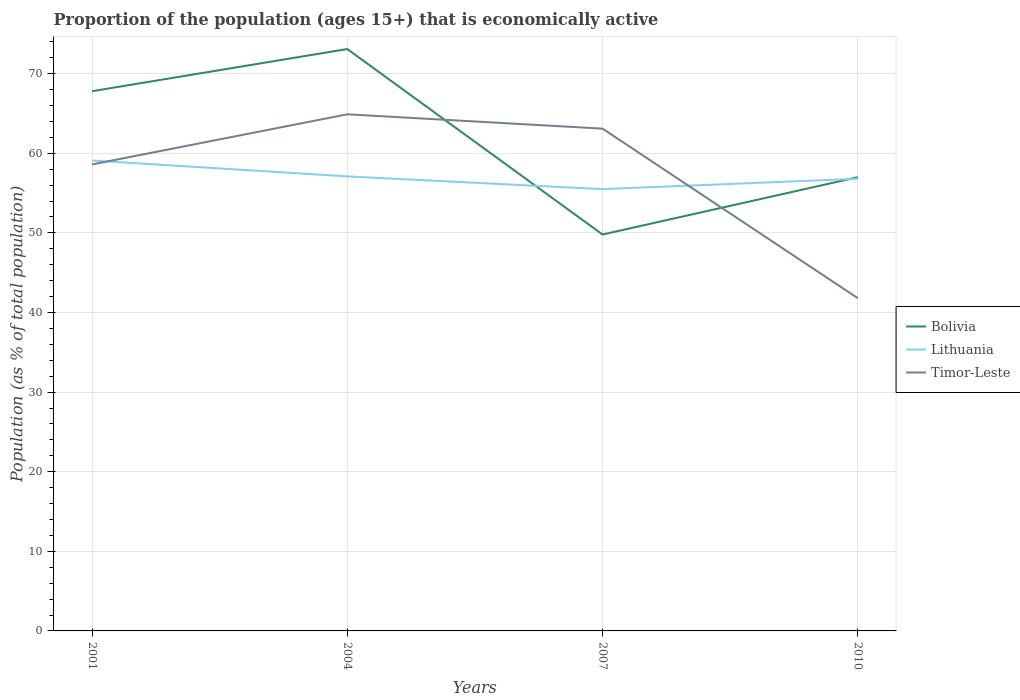How many different coloured lines are there?
Your answer should be compact. 3. Across all years, what is the maximum proportion of the population that is economically active in Bolivia?
Provide a succinct answer. 49.8. In which year was the proportion of the population that is economically active in Timor-Leste maximum?
Offer a terse response. 2010. What is the total proportion of the population that is economically active in Timor-Leste in the graph?
Give a very brief answer. 21.3. What is the difference between the highest and the second highest proportion of the population that is economically active in Timor-Leste?
Offer a terse response. 23.1. Is the proportion of the population that is economically active in Bolivia strictly greater than the proportion of the population that is economically active in Lithuania over the years?
Offer a terse response. No. How many lines are there?
Your answer should be compact. 3. How many years are there in the graph?
Your answer should be compact. 4. Does the graph contain grids?
Offer a very short reply. Yes. How many legend labels are there?
Your answer should be compact. 3. What is the title of the graph?
Your answer should be very brief. Proportion of the population (ages 15+) that is economically active. Does "Switzerland" appear as one of the legend labels in the graph?
Offer a very short reply. No. What is the label or title of the Y-axis?
Give a very brief answer. Population (as % of total population). What is the Population (as % of total population) in Bolivia in 2001?
Offer a very short reply. 67.8. What is the Population (as % of total population) in Lithuania in 2001?
Make the answer very short. 59.1. What is the Population (as % of total population) in Timor-Leste in 2001?
Provide a succinct answer. 58.6. What is the Population (as % of total population) in Bolivia in 2004?
Ensure brevity in your answer.  73.1. What is the Population (as % of total population) of Lithuania in 2004?
Offer a terse response. 57.1. What is the Population (as % of total population) in Timor-Leste in 2004?
Give a very brief answer. 64.9. What is the Population (as % of total population) in Bolivia in 2007?
Your response must be concise. 49.8. What is the Population (as % of total population) in Lithuania in 2007?
Keep it short and to the point. 55.5. What is the Population (as % of total population) in Timor-Leste in 2007?
Offer a terse response. 63.1. What is the Population (as % of total population) of Bolivia in 2010?
Your response must be concise. 57. What is the Population (as % of total population) in Lithuania in 2010?
Your response must be concise. 56.8. What is the Population (as % of total population) in Timor-Leste in 2010?
Your response must be concise. 41.8. Across all years, what is the maximum Population (as % of total population) in Bolivia?
Provide a short and direct response. 73.1. Across all years, what is the maximum Population (as % of total population) of Lithuania?
Make the answer very short. 59.1. Across all years, what is the maximum Population (as % of total population) of Timor-Leste?
Offer a terse response. 64.9. Across all years, what is the minimum Population (as % of total population) of Bolivia?
Offer a terse response. 49.8. Across all years, what is the minimum Population (as % of total population) of Lithuania?
Provide a succinct answer. 55.5. Across all years, what is the minimum Population (as % of total population) of Timor-Leste?
Provide a short and direct response. 41.8. What is the total Population (as % of total population) of Bolivia in the graph?
Your response must be concise. 247.7. What is the total Population (as % of total population) in Lithuania in the graph?
Offer a terse response. 228.5. What is the total Population (as % of total population) of Timor-Leste in the graph?
Give a very brief answer. 228.4. What is the difference between the Population (as % of total population) in Bolivia in 2001 and that in 2004?
Provide a short and direct response. -5.3. What is the difference between the Population (as % of total population) in Lithuania in 2001 and that in 2004?
Provide a short and direct response. 2. What is the difference between the Population (as % of total population) in Timor-Leste in 2001 and that in 2004?
Offer a very short reply. -6.3. What is the difference between the Population (as % of total population) in Lithuania in 2001 and that in 2007?
Offer a terse response. 3.6. What is the difference between the Population (as % of total population) in Timor-Leste in 2001 and that in 2007?
Offer a terse response. -4.5. What is the difference between the Population (as % of total population) of Lithuania in 2001 and that in 2010?
Keep it short and to the point. 2.3. What is the difference between the Population (as % of total population) of Timor-Leste in 2001 and that in 2010?
Make the answer very short. 16.8. What is the difference between the Population (as % of total population) in Bolivia in 2004 and that in 2007?
Offer a terse response. 23.3. What is the difference between the Population (as % of total population) of Timor-Leste in 2004 and that in 2007?
Provide a succinct answer. 1.8. What is the difference between the Population (as % of total population) in Bolivia in 2004 and that in 2010?
Provide a short and direct response. 16.1. What is the difference between the Population (as % of total population) of Lithuania in 2004 and that in 2010?
Ensure brevity in your answer.  0.3. What is the difference between the Population (as % of total population) of Timor-Leste in 2004 and that in 2010?
Provide a short and direct response. 23.1. What is the difference between the Population (as % of total population) of Timor-Leste in 2007 and that in 2010?
Offer a terse response. 21.3. What is the difference between the Population (as % of total population) in Bolivia in 2001 and the Population (as % of total population) in Lithuania in 2007?
Provide a succinct answer. 12.3. What is the difference between the Population (as % of total population) in Lithuania in 2001 and the Population (as % of total population) in Timor-Leste in 2007?
Your answer should be compact. -4. What is the difference between the Population (as % of total population) of Bolivia in 2001 and the Population (as % of total population) of Lithuania in 2010?
Keep it short and to the point. 11. What is the difference between the Population (as % of total population) of Bolivia in 2001 and the Population (as % of total population) of Timor-Leste in 2010?
Ensure brevity in your answer.  26. What is the difference between the Population (as % of total population) in Bolivia in 2004 and the Population (as % of total population) in Lithuania in 2007?
Ensure brevity in your answer.  17.6. What is the difference between the Population (as % of total population) in Bolivia in 2004 and the Population (as % of total population) in Timor-Leste in 2007?
Ensure brevity in your answer.  10. What is the difference between the Population (as % of total population) of Lithuania in 2004 and the Population (as % of total population) of Timor-Leste in 2007?
Provide a short and direct response. -6. What is the difference between the Population (as % of total population) in Bolivia in 2004 and the Population (as % of total population) in Timor-Leste in 2010?
Ensure brevity in your answer.  31.3. What is the difference between the Population (as % of total population) of Lithuania in 2004 and the Population (as % of total population) of Timor-Leste in 2010?
Ensure brevity in your answer.  15.3. What is the difference between the Population (as % of total population) of Bolivia in 2007 and the Population (as % of total population) of Lithuania in 2010?
Provide a succinct answer. -7. What is the average Population (as % of total population) in Bolivia per year?
Your response must be concise. 61.92. What is the average Population (as % of total population) in Lithuania per year?
Provide a short and direct response. 57.12. What is the average Population (as % of total population) in Timor-Leste per year?
Give a very brief answer. 57.1. In the year 2001, what is the difference between the Population (as % of total population) of Lithuania and Population (as % of total population) of Timor-Leste?
Ensure brevity in your answer.  0.5. In the year 2004, what is the difference between the Population (as % of total population) in Lithuania and Population (as % of total population) in Timor-Leste?
Ensure brevity in your answer.  -7.8. In the year 2007, what is the difference between the Population (as % of total population) of Bolivia and Population (as % of total population) of Lithuania?
Make the answer very short. -5.7. In the year 2007, what is the difference between the Population (as % of total population) in Bolivia and Population (as % of total population) in Timor-Leste?
Provide a succinct answer. -13.3. In the year 2010, what is the difference between the Population (as % of total population) of Bolivia and Population (as % of total population) of Lithuania?
Offer a terse response. 0.2. In the year 2010, what is the difference between the Population (as % of total population) in Bolivia and Population (as % of total population) in Timor-Leste?
Give a very brief answer. 15.2. What is the ratio of the Population (as % of total population) in Bolivia in 2001 to that in 2004?
Provide a succinct answer. 0.93. What is the ratio of the Population (as % of total population) of Lithuania in 2001 to that in 2004?
Ensure brevity in your answer.  1.03. What is the ratio of the Population (as % of total population) of Timor-Leste in 2001 to that in 2004?
Offer a very short reply. 0.9. What is the ratio of the Population (as % of total population) of Bolivia in 2001 to that in 2007?
Offer a terse response. 1.36. What is the ratio of the Population (as % of total population) in Lithuania in 2001 to that in 2007?
Make the answer very short. 1.06. What is the ratio of the Population (as % of total population) in Timor-Leste in 2001 to that in 2007?
Your response must be concise. 0.93. What is the ratio of the Population (as % of total population) of Bolivia in 2001 to that in 2010?
Your answer should be compact. 1.19. What is the ratio of the Population (as % of total population) of Lithuania in 2001 to that in 2010?
Provide a succinct answer. 1.04. What is the ratio of the Population (as % of total population) of Timor-Leste in 2001 to that in 2010?
Your answer should be compact. 1.4. What is the ratio of the Population (as % of total population) in Bolivia in 2004 to that in 2007?
Your answer should be very brief. 1.47. What is the ratio of the Population (as % of total population) of Lithuania in 2004 to that in 2007?
Give a very brief answer. 1.03. What is the ratio of the Population (as % of total population) in Timor-Leste in 2004 to that in 2007?
Your answer should be compact. 1.03. What is the ratio of the Population (as % of total population) in Bolivia in 2004 to that in 2010?
Keep it short and to the point. 1.28. What is the ratio of the Population (as % of total population) in Lithuania in 2004 to that in 2010?
Give a very brief answer. 1.01. What is the ratio of the Population (as % of total population) in Timor-Leste in 2004 to that in 2010?
Ensure brevity in your answer.  1.55. What is the ratio of the Population (as % of total population) in Bolivia in 2007 to that in 2010?
Ensure brevity in your answer.  0.87. What is the ratio of the Population (as % of total population) in Lithuania in 2007 to that in 2010?
Ensure brevity in your answer.  0.98. What is the ratio of the Population (as % of total population) of Timor-Leste in 2007 to that in 2010?
Your response must be concise. 1.51. What is the difference between the highest and the second highest Population (as % of total population) in Bolivia?
Ensure brevity in your answer.  5.3. What is the difference between the highest and the second highest Population (as % of total population) in Timor-Leste?
Ensure brevity in your answer.  1.8. What is the difference between the highest and the lowest Population (as % of total population) in Bolivia?
Your answer should be very brief. 23.3. What is the difference between the highest and the lowest Population (as % of total population) in Timor-Leste?
Your answer should be very brief. 23.1. 